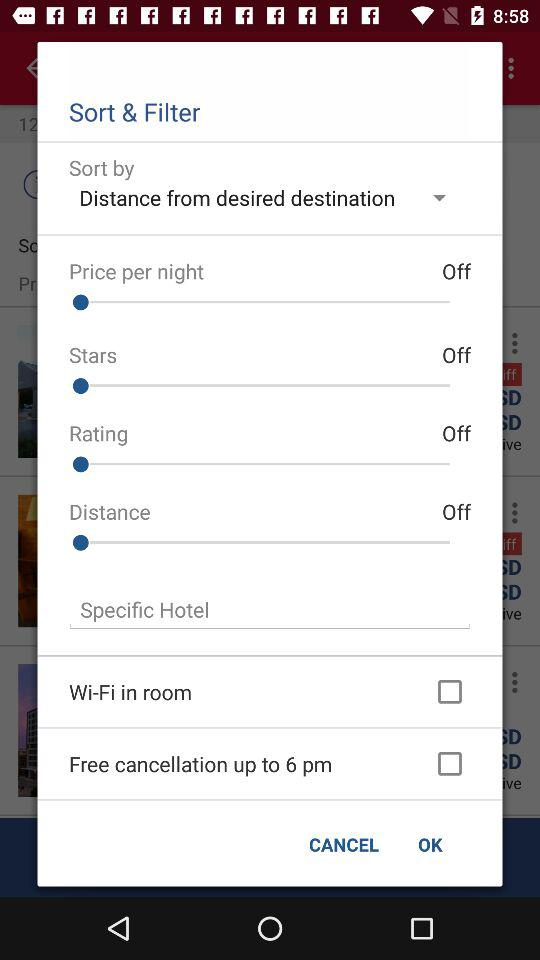How many options are available for sorting by?
Answer the question using a single word or phrase. 5 